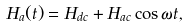<formula> <loc_0><loc_0><loc_500><loc_500>H _ { a } ( t ) = H _ { d c } + H _ { a c } \cos \omega t ,</formula> 